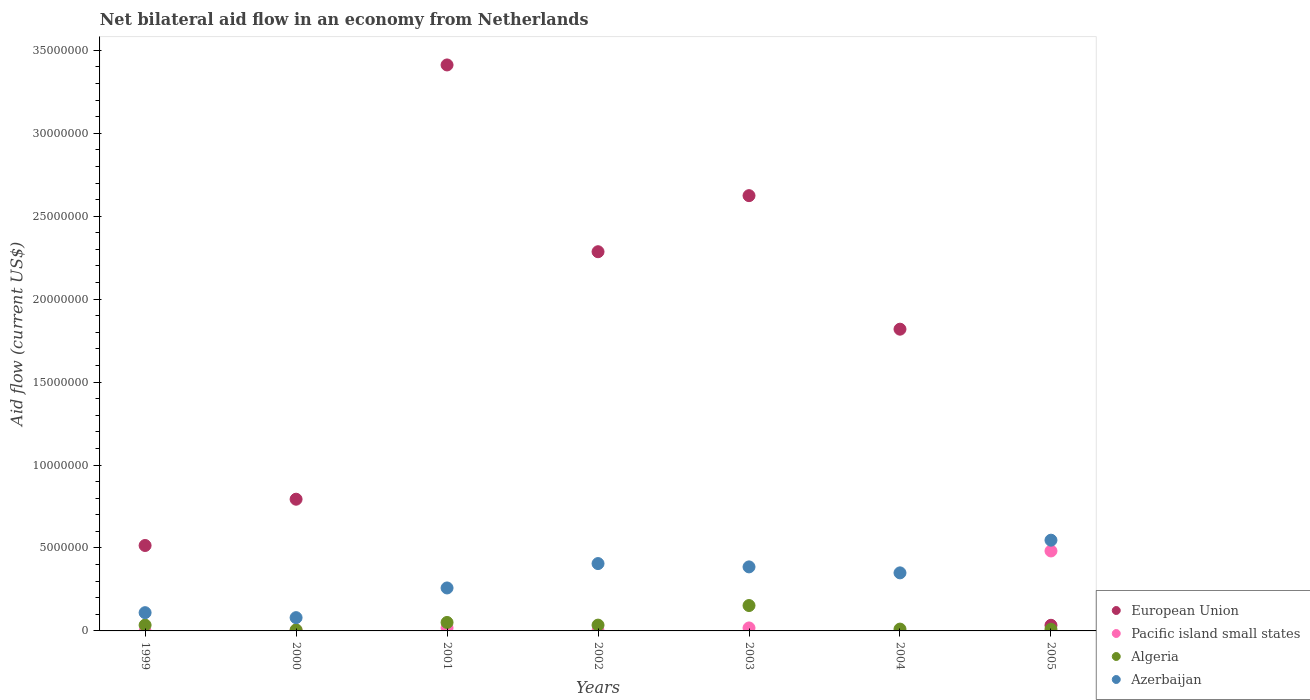Is the number of dotlines equal to the number of legend labels?
Your answer should be compact. No. What is the net bilateral aid flow in Azerbaijan in 2001?
Provide a succinct answer. 2.59e+06. Across all years, what is the maximum net bilateral aid flow in Azerbaijan?
Give a very brief answer. 5.47e+06. Across all years, what is the minimum net bilateral aid flow in Algeria?
Your answer should be very brief. 6.00e+04. In which year was the net bilateral aid flow in European Union maximum?
Give a very brief answer. 2001. What is the total net bilateral aid flow in European Union in the graph?
Provide a short and direct response. 1.15e+08. What is the difference between the net bilateral aid flow in Azerbaijan in 2000 and that in 2002?
Ensure brevity in your answer.  -3.26e+06. What is the difference between the net bilateral aid flow in Pacific island small states in 2003 and the net bilateral aid flow in European Union in 2001?
Ensure brevity in your answer.  -3.39e+07. What is the average net bilateral aid flow in Azerbaijan per year?
Offer a very short reply. 3.05e+06. In the year 2001, what is the difference between the net bilateral aid flow in Pacific island small states and net bilateral aid flow in Algeria?
Ensure brevity in your answer.  -3.30e+05. In how many years, is the net bilateral aid flow in Azerbaijan greater than 30000000 US$?
Keep it short and to the point. 0. What is the ratio of the net bilateral aid flow in European Union in 2001 to that in 2004?
Offer a terse response. 1.88. What is the difference between the highest and the second highest net bilateral aid flow in Pacific island small states?
Provide a short and direct response. 4.64e+06. What is the difference between the highest and the lowest net bilateral aid flow in European Union?
Provide a succinct answer. 3.38e+07. In how many years, is the net bilateral aid flow in Azerbaijan greater than the average net bilateral aid flow in Azerbaijan taken over all years?
Provide a short and direct response. 4. Is it the case that in every year, the sum of the net bilateral aid flow in European Union and net bilateral aid flow in Azerbaijan  is greater than the net bilateral aid flow in Algeria?
Your answer should be compact. Yes. Is the net bilateral aid flow in Azerbaijan strictly greater than the net bilateral aid flow in Pacific island small states over the years?
Your answer should be very brief. Yes. How many dotlines are there?
Provide a succinct answer. 4. How many years are there in the graph?
Provide a succinct answer. 7. Does the graph contain grids?
Offer a very short reply. No. Where does the legend appear in the graph?
Make the answer very short. Bottom right. How are the legend labels stacked?
Provide a succinct answer. Vertical. What is the title of the graph?
Provide a succinct answer. Net bilateral aid flow in an economy from Netherlands. What is the label or title of the X-axis?
Provide a succinct answer. Years. What is the Aid flow (current US$) of European Union in 1999?
Offer a very short reply. 5.15e+06. What is the Aid flow (current US$) in Azerbaijan in 1999?
Your answer should be very brief. 1.10e+06. What is the Aid flow (current US$) of European Union in 2000?
Give a very brief answer. 7.94e+06. What is the Aid flow (current US$) of European Union in 2001?
Your answer should be compact. 3.41e+07. What is the Aid flow (current US$) in Algeria in 2001?
Offer a very short reply. 5.10e+05. What is the Aid flow (current US$) of Azerbaijan in 2001?
Offer a terse response. 2.59e+06. What is the Aid flow (current US$) in European Union in 2002?
Your answer should be compact. 2.29e+07. What is the Aid flow (current US$) of Pacific island small states in 2002?
Keep it short and to the point. 10000. What is the Aid flow (current US$) in Azerbaijan in 2002?
Provide a short and direct response. 4.06e+06. What is the Aid flow (current US$) of European Union in 2003?
Your response must be concise. 2.62e+07. What is the Aid flow (current US$) in Algeria in 2003?
Provide a short and direct response. 1.53e+06. What is the Aid flow (current US$) in Azerbaijan in 2003?
Provide a short and direct response. 3.86e+06. What is the Aid flow (current US$) in European Union in 2004?
Ensure brevity in your answer.  1.82e+07. What is the Aid flow (current US$) in Azerbaijan in 2004?
Provide a succinct answer. 3.50e+06. What is the Aid flow (current US$) in Pacific island small states in 2005?
Ensure brevity in your answer.  4.82e+06. What is the Aid flow (current US$) in Azerbaijan in 2005?
Offer a very short reply. 5.47e+06. Across all years, what is the maximum Aid flow (current US$) of European Union?
Your response must be concise. 3.41e+07. Across all years, what is the maximum Aid flow (current US$) of Pacific island small states?
Ensure brevity in your answer.  4.82e+06. Across all years, what is the maximum Aid flow (current US$) in Algeria?
Ensure brevity in your answer.  1.53e+06. Across all years, what is the maximum Aid flow (current US$) of Azerbaijan?
Offer a very short reply. 5.47e+06. Across all years, what is the minimum Aid flow (current US$) of Azerbaijan?
Keep it short and to the point. 8.00e+05. What is the total Aid flow (current US$) in European Union in the graph?
Your answer should be compact. 1.15e+08. What is the total Aid flow (current US$) in Pacific island small states in the graph?
Provide a succinct answer. 5.22e+06. What is the total Aid flow (current US$) of Algeria in the graph?
Give a very brief answer. 3.01e+06. What is the total Aid flow (current US$) in Azerbaijan in the graph?
Provide a succinct answer. 2.14e+07. What is the difference between the Aid flow (current US$) in European Union in 1999 and that in 2000?
Make the answer very short. -2.79e+06. What is the difference between the Aid flow (current US$) in European Union in 1999 and that in 2001?
Keep it short and to the point. -2.90e+07. What is the difference between the Aid flow (current US$) of Algeria in 1999 and that in 2001?
Provide a short and direct response. -1.60e+05. What is the difference between the Aid flow (current US$) of Azerbaijan in 1999 and that in 2001?
Your answer should be very brief. -1.49e+06. What is the difference between the Aid flow (current US$) in European Union in 1999 and that in 2002?
Offer a terse response. -1.77e+07. What is the difference between the Aid flow (current US$) in Azerbaijan in 1999 and that in 2002?
Your answer should be very brief. -2.96e+06. What is the difference between the Aid flow (current US$) in European Union in 1999 and that in 2003?
Offer a very short reply. -2.11e+07. What is the difference between the Aid flow (current US$) of Algeria in 1999 and that in 2003?
Provide a succinct answer. -1.18e+06. What is the difference between the Aid flow (current US$) of Azerbaijan in 1999 and that in 2003?
Your answer should be very brief. -2.76e+06. What is the difference between the Aid flow (current US$) of European Union in 1999 and that in 2004?
Keep it short and to the point. -1.30e+07. What is the difference between the Aid flow (current US$) of Algeria in 1999 and that in 2004?
Your answer should be very brief. 2.40e+05. What is the difference between the Aid flow (current US$) of Azerbaijan in 1999 and that in 2004?
Ensure brevity in your answer.  -2.40e+06. What is the difference between the Aid flow (current US$) of European Union in 1999 and that in 2005?
Keep it short and to the point. 4.81e+06. What is the difference between the Aid flow (current US$) of Algeria in 1999 and that in 2005?
Provide a succinct answer. 2.50e+05. What is the difference between the Aid flow (current US$) of Azerbaijan in 1999 and that in 2005?
Provide a succinct answer. -4.37e+06. What is the difference between the Aid flow (current US$) in European Union in 2000 and that in 2001?
Offer a very short reply. -2.62e+07. What is the difference between the Aid flow (current US$) in Algeria in 2000 and that in 2001?
Your response must be concise. -4.50e+05. What is the difference between the Aid flow (current US$) of Azerbaijan in 2000 and that in 2001?
Make the answer very short. -1.79e+06. What is the difference between the Aid flow (current US$) of European Union in 2000 and that in 2002?
Your answer should be very brief. -1.49e+07. What is the difference between the Aid flow (current US$) in Pacific island small states in 2000 and that in 2002?
Your answer should be compact. 2.00e+04. What is the difference between the Aid flow (current US$) in Algeria in 2000 and that in 2002?
Provide a succinct answer. -2.90e+05. What is the difference between the Aid flow (current US$) of Azerbaijan in 2000 and that in 2002?
Your answer should be very brief. -3.26e+06. What is the difference between the Aid flow (current US$) in European Union in 2000 and that in 2003?
Your response must be concise. -1.83e+07. What is the difference between the Aid flow (current US$) in Algeria in 2000 and that in 2003?
Provide a succinct answer. -1.47e+06. What is the difference between the Aid flow (current US$) of Azerbaijan in 2000 and that in 2003?
Make the answer very short. -3.06e+06. What is the difference between the Aid flow (current US$) in European Union in 2000 and that in 2004?
Keep it short and to the point. -1.02e+07. What is the difference between the Aid flow (current US$) in Algeria in 2000 and that in 2004?
Your response must be concise. -5.00e+04. What is the difference between the Aid flow (current US$) of Azerbaijan in 2000 and that in 2004?
Offer a terse response. -2.70e+06. What is the difference between the Aid flow (current US$) of European Union in 2000 and that in 2005?
Your response must be concise. 7.60e+06. What is the difference between the Aid flow (current US$) in Pacific island small states in 2000 and that in 2005?
Your answer should be compact. -4.79e+06. What is the difference between the Aid flow (current US$) of Algeria in 2000 and that in 2005?
Provide a succinct answer. -4.00e+04. What is the difference between the Aid flow (current US$) in Azerbaijan in 2000 and that in 2005?
Ensure brevity in your answer.  -4.67e+06. What is the difference between the Aid flow (current US$) in European Union in 2001 and that in 2002?
Make the answer very short. 1.13e+07. What is the difference between the Aid flow (current US$) of Pacific island small states in 2001 and that in 2002?
Your answer should be compact. 1.70e+05. What is the difference between the Aid flow (current US$) of Azerbaijan in 2001 and that in 2002?
Give a very brief answer. -1.47e+06. What is the difference between the Aid flow (current US$) of European Union in 2001 and that in 2003?
Keep it short and to the point. 7.88e+06. What is the difference between the Aid flow (current US$) in Algeria in 2001 and that in 2003?
Your response must be concise. -1.02e+06. What is the difference between the Aid flow (current US$) of Azerbaijan in 2001 and that in 2003?
Make the answer very short. -1.27e+06. What is the difference between the Aid flow (current US$) in European Union in 2001 and that in 2004?
Offer a terse response. 1.59e+07. What is the difference between the Aid flow (current US$) of Azerbaijan in 2001 and that in 2004?
Keep it short and to the point. -9.10e+05. What is the difference between the Aid flow (current US$) of European Union in 2001 and that in 2005?
Ensure brevity in your answer.  3.38e+07. What is the difference between the Aid flow (current US$) in Pacific island small states in 2001 and that in 2005?
Your response must be concise. -4.64e+06. What is the difference between the Aid flow (current US$) of Algeria in 2001 and that in 2005?
Offer a very short reply. 4.10e+05. What is the difference between the Aid flow (current US$) of Azerbaijan in 2001 and that in 2005?
Provide a short and direct response. -2.88e+06. What is the difference between the Aid flow (current US$) of European Union in 2002 and that in 2003?
Your answer should be compact. -3.38e+06. What is the difference between the Aid flow (current US$) of Pacific island small states in 2002 and that in 2003?
Make the answer very short. -1.70e+05. What is the difference between the Aid flow (current US$) of Algeria in 2002 and that in 2003?
Give a very brief answer. -1.18e+06. What is the difference between the Aid flow (current US$) in European Union in 2002 and that in 2004?
Your answer should be compact. 4.67e+06. What is the difference between the Aid flow (current US$) in Algeria in 2002 and that in 2004?
Your answer should be compact. 2.40e+05. What is the difference between the Aid flow (current US$) of Azerbaijan in 2002 and that in 2004?
Offer a terse response. 5.60e+05. What is the difference between the Aid flow (current US$) in European Union in 2002 and that in 2005?
Make the answer very short. 2.25e+07. What is the difference between the Aid flow (current US$) of Pacific island small states in 2002 and that in 2005?
Provide a succinct answer. -4.81e+06. What is the difference between the Aid flow (current US$) of Algeria in 2002 and that in 2005?
Your response must be concise. 2.50e+05. What is the difference between the Aid flow (current US$) of Azerbaijan in 2002 and that in 2005?
Your answer should be compact. -1.41e+06. What is the difference between the Aid flow (current US$) of European Union in 2003 and that in 2004?
Your answer should be compact. 8.05e+06. What is the difference between the Aid flow (current US$) of Algeria in 2003 and that in 2004?
Provide a succinct answer. 1.42e+06. What is the difference between the Aid flow (current US$) in Azerbaijan in 2003 and that in 2004?
Your answer should be very brief. 3.60e+05. What is the difference between the Aid flow (current US$) of European Union in 2003 and that in 2005?
Your answer should be compact. 2.59e+07. What is the difference between the Aid flow (current US$) in Pacific island small states in 2003 and that in 2005?
Your answer should be compact. -4.64e+06. What is the difference between the Aid flow (current US$) of Algeria in 2003 and that in 2005?
Offer a very short reply. 1.43e+06. What is the difference between the Aid flow (current US$) of Azerbaijan in 2003 and that in 2005?
Provide a short and direct response. -1.61e+06. What is the difference between the Aid flow (current US$) in European Union in 2004 and that in 2005?
Ensure brevity in your answer.  1.78e+07. What is the difference between the Aid flow (current US$) in Algeria in 2004 and that in 2005?
Keep it short and to the point. 10000. What is the difference between the Aid flow (current US$) of Azerbaijan in 2004 and that in 2005?
Provide a succinct answer. -1.97e+06. What is the difference between the Aid flow (current US$) of European Union in 1999 and the Aid flow (current US$) of Pacific island small states in 2000?
Keep it short and to the point. 5.12e+06. What is the difference between the Aid flow (current US$) in European Union in 1999 and the Aid flow (current US$) in Algeria in 2000?
Your answer should be compact. 5.09e+06. What is the difference between the Aid flow (current US$) of European Union in 1999 and the Aid flow (current US$) of Azerbaijan in 2000?
Offer a terse response. 4.35e+06. What is the difference between the Aid flow (current US$) of Algeria in 1999 and the Aid flow (current US$) of Azerbaijan in 2000?
Ensure brevity in your answer.  -4.50e+05. What is the difference between the Aid flow (current US$) in European Union in 1999 and the Aid flow (current US$) in Pacific island small states in 2001?
Make the answer very short. 4.97e+06. What is the difference between the Aid flow (current US$) of European Union in 1999 and the Aid flow (current US$) of Algeria in 2001?
Make the answer very short. 4.64e+06. What is the difference between the Aid flow (current US$) in European Union in 1999 and the Aid flow (current US$) in Azerbaijan in 2001?
Offer a very short reply. 2.56e+06. What is the difference between the Aid flow (current US$) of Algeria in 1999 and the Aid flow (current US$) of Azerbaijan in 2001?
Offer a very short reply. -2.24e+06. What is the difference between the Aid flow (current US$) of European Union in 1999 and the Aid flow (current US$) of Pacific island small states in 2002?
Your answer should be compact. 5.14e+06. What is the difference between the Aid flow (current US$) in European Union in 1999 and the Aid flow (current US$) in Algeria in 2002?
Your response must be concise. 4.80e+06. What is the difference between the Aid flow (current US$) of European Union in 1999 and the Aid flow (current US$) of Azerbaijan in 2002?
Your answer should be compact. 1.09e+06. What is the difference between the Aid flow (current US$) in Algeria in 1999 and the Aid flow (current US$) in Azerbaijan in 2002?
Provide a succinct answer. -3.71e+06. What is the difference between the Aid flow (current US$) in European Union in 1999 and the Aid flow (current US$) in Pacific island small states in 2003?
Offer a terse response. 4.97e+06. What is the difference between the Aid flow (current US$) in European Union in 1999 and the Aid flow (current US$) in Algeria in 2003?
Make the answer very short. 3.62e+06. What is the difference between the Aid flow (current US$) of European Union in 1999 and the Aid flow (current US$) of Azerbaijan in 2003?
Make the answer very short. 1.29e+06. What is the difference between the Aid flow (current US$) of Algeria in 1999 and the Aid flow (current US$) of Azerbaijan in 2003?
Your response must be concise. -3.51e+06. What is the difference between the Aid flow (current US$) of European Union in 1999 and the Aid flow (current US$) of Algeria in 2004?
Your answer should be compact. 5.04e+06. What is the difference between the Aid flow (current US$) in European Union in 1999 and the Aid flow (current US$) in Azerbaijan in 2004?
Provide a short and direct response. 1.65e+06. What is the difference between the Aid flow (current US$) of Algeria in 1999 and the Aid flow (current US$) of Azerbaijan in 2004?
Your answer should be compact. -3.15e+06. What is the difference between the Aid flow (current US$) of European Union in 1999 and the Aid flow (current US$) of Algeria in 2005?
Provide a short and direct response. 5.05e+06. What is the difference between the Aid flow (current US$) in European Union in 1999 and the Aid flow (current US$) in Azerbaijan in 2005?
Your answer should be very brief. -3.20e+05. What is the difference between the Aid flow (current US$) in Algeria in 1999 and the Aid flow (current US$) in Azerbaijan in 2005?
Ensure brevity in your answer.  -5.12e+06. What is the difference between the Aid flow (current US$) of European Union in 2000 and the Aid flow (current US$) of Pacific island small states in 2001?
Make the answer very short. 7.76e+06. What is the difference between the Aid flow (current US$) in European Union in 2000 and the Aid flow (current US$) in Algeria in 2001?
Provide a succinct answer. 7.43e+06. What is the difference between the Aid flow (current US$) of European Union in 2000 and the Aid flow (current US$) of Azerbaijan in 2001?
Ensure brevity in your answer.  5.35e+06. What is the difference between the Aid flow (current US$) of Pacific island small states in 2000 and the Aid flow (current US$) of Algeria in 2001?
Offer a terse response. -4.80e+05. What is the difference between the Aid flow (current US$) in Pacific island small states in 2000 and the Aid flow (current US$) in Azerbaijan in 2001?
Provide a succinct answer. -2.56e+06. What is the difference between the Aid flow (current US$) in Algeria in 2000 and the Aid flow (current US$) in Azerbaijan in 2001?
Your answer should be compact. -2.53e+06. What is the difference between the Aid flow (current US$) in European Union in 2000 and the Aid flow (current US$) in Pacific island small states in 2002?
Your response must be concise. 7.93e+06. What is the difference between the Aid flow (current US$) of European Union in 2000 and the Aid flow (current US$) of Algeria in 2002?
Provide a short and direct response. 7.59e+06. What is the difference between the Aid flow (current US$) in European Union in 2000 and the Aid flow (current US$) in Azerbaijan in 2002?
Offer a very short reply. 3.88e+06. What is the difference between the Aid flow (current US$) of Pacific island small states in 2000 and the Aid flow (current US$) of Algeria in 2002?
Keep it short and to the point. -3.20e+05. What is the difference between the Aid flow (current US$) in Pacific island small states in 2000 and the Aid flow (current US$) in Azerbaijan in 2002?
Provide a short and direct response. -4.03e+06. What is the difference between the Aid flow (current US$) of European Union in 2000 and the Aid flow (current US$) of Pacific island small states in 2003?
Make the answer very short. 7.76e+06. What is the difference between the Aid flow (current US$) of European Union in 2000 and the Aid flow (current US$) of Algeria in 2003?
Offer a very short reply. 6.41e+06. What is the difference between the Aid flow (current US$) in European Union in 2000 and the Aid flow (current US$) in Azerbaijan in 2003?
Offer a very short reply. 4.08e+06. What is the difference between the Aid flow (current US$) in Pacific island small states in 2000 and the Aid flow (current US$) in Algeria in 2003?
Your response must be concise. -1.50e+06. What is the difference between the Aid flow (current US$) in Pacific island small states in 2000 and the Aid flow (current US$) in Azerbaijan in 2003?
Provide a succinct answer. -3.83e+06. What is the difference between the Aid flow (current US$) of Algeria in 2000 and the Aid flow (current US$) of Azerbaijan in 2003?
Provide a short and direct response. -3.80e+06. What is the difference between the Aid flow (current US$) of European Union in 2000 and the Aid flow (current US$) of Algeria in 2004?
Make the answer very short. 7.83e+06. What is the difference between the Aid flow (current US$) in European Union in 2000 and the Aid flow (current US$) in Azerbaijan in 2004?
Your answer should be compact. 4.44e+06. What is the difference between the Aid flow (current US$) of Pacific island small states in 2000 and the Aid flow (current US$) of Algeria in 2004?
Provide a succinct answer. -8.00e+04. What is the difference between the Aid flow (current US$) in Pacific island small states in 2000 and the Aid flow (current US$) in Azerbaijan in 2004?
Make the answer very short. -3.47e+06. What is the difference between the Aid flow (current US$) of Algeria in 2000 and the Aid flow (current US$) of Azerbaijan in 2004?
Keep it short and to the point. -3.44e+06. What is the difference between the Aid flow (current US$) of European Union in 2000 and the Aid flow (current US$) of Pacific island small states in 2005?
Your answer should be compact. 3.12e+06. What is the difference between the Aid flow (current US$) of European Union in 2000 and the Aid flow (current US$) of Algeria in 2005?
Your answer should be compact. 7.84e+06. What is the difference between the Aid flow (current US$) of European Union in 2000 and the Aid flow (current US$) of Azerbaijan in 2005?
Offer a terse response. 2.47e+06. What is the difference between the Aid flow (current US$) in Pacific island small states in 2000 and the Aid flow (current US$) in Algeria in 2005?
Offer a terse response. -7.00e+04. What is the difference between the Aid flow (current US$) in Pacific island small states in 2000 and the Aid flow (current US$) in Azerbaijan in 2005?
Provide a succinct answer. -5.44e+06. What is the difference between the Aid flow (current US$) of Algeria in 2000 and the Aid flow (current US$) of Azerbaijan in 2005?
Give a very brief answer. -5.41e+06. What is the difference between the Aid flow (current US$) in European Union in 2001 and the Aid flow (current US$) in Pacific island small states in 2002?
Ensure brevity in your answer.  3.41e+07. What is the difference between the Aid flow (current US$) of European Union in 2001 and the Aid flow (current US$) of Algeria in 2002?
Provide a short and direct response. 3.38e+07. What is the difference between the Aid flow (current US$) of European Union in 2001 and the Aid flow (current US$) of Azerbaijan in 2002?
Your answer should be compact. 3.01e+07. What is the difference between the Aid flow (current US$) in Pacific island small states in 2001 and the Aid flow (current US$) in Algeria in 2002?
Your answer should be compact. -1.70e+05. What is the difference between the Aid flow (current US$) in Pacific island small states in 2001 and the Aid flow (current US$) in Azerbaijan in 2002?
Offer a terse response. -3.88e+06. What is the difference between the Aid flow (current US$) of Algeria in 2001 and the Aid flow (current US$) of Azerbaijan in 2002?
Your answer should be compact. -3.55e+06. What is the difference between the Aid flow (current US$) in European Union in 2001 and the Aid flow (current US$) in Pacific island small states in 2003?
Offer a terse response. 3.39e+07. What is the difference between the Aid flow (current US$) in European Union in 2001 and the Aid flow (current US$) in Algeria in 2003?
Offer a very short reply. 3.26e+07. What is the difference between the Aid flow (current US$) of European Union in 2001 and the Aid flow (current US$) of Azerbaijan in 2003?
Provide a succinct answer. 3.03e+07. What is the difference between the Aid flow (current US$) of Pacific island small states in 2001 and the Aid flow (current US$) of Algeria in 2003?
Give a very brief answer. -1.35e+06. What is the difference between the Aid flow (current US$) in Pacific island small states in 2001 and the Aid flow (current US$) in Azerbaijan in 2003?
Provide a short and direct response. -3.68e+06. What is the difference between the Aid flow (current US$) in Algeria in 2001 and the Aid flow (current US$) in Azerbaijan in 2003?
Ensure brevity in your answer.  -3.35e+06. What is the difference between the Aid flow (current US$) of European Union in 2001 and the Aid flow (current US$) of Algeria in 2004?
Make the answer very short. 3.40e+07. What is the difference between the Aid flow (current US$) in European Union in 2001 and the Aid flow (current US$) in Azerbaijan in 2004?
Provide a succinct answer. 3.06e+07. What is the difference between the Aid flow (current US$) of Pacific island small states in 2001 and the Aid flow (current US$) of Algeria in 2004?
Ensure brevity in your answer.  7.00e+04. What is the difference between the Aid flow (current US$) of Pacific island small states in 2001 and the Aid flow (current US$) of Azerbaijan in 2004?
Give a very brief answer. -3.32e+06. What is the difference between the Aid flow (current US$) in Algeria in 2001 and the Aid flow (current US$) in Azerbaijan in 2004?
Make the answer very short. -2.99e+06. What is the difference between the Aid flow (current US$) of European Union in 2001 and the Aid flow (current US$) of Pacific island small states in 2005?
Ensure brevity in your answer.  2.93e+07. What is the difference between the Aid flow (current US$) of European Union in 2001 and the Aid flow (current US$) of Algeria in 2005?
Ensure brevity in your answer.  3.40e+07. What is the difference between the Aid flow (current US$) of European Union in 2001 and the Aid flow (current US$) of Azerbaijan in 2005?
Keep it short and to the point. 2.86e+07. What is the difference between the Aid flow (current US$) in Pacific island small states in 2001 and the Aid flow (current US$) in Algeria in 2005?
Ensure brevity in your answer.  8.00e+04. What is the difference between the Aid flow (current US$) in Pacific island small states in 2001 and the Aid flow (current US$) in Azerbaijan in 2005?
Offer a very short reply. -5.29e+06. What is the difference between the Aid flow (current US$) of Algeria in 2001 and the Aid flow (current US$) of Azerbaijan in 2005?
Keep it short and to the point. -4.96e+06. What is the difference between the Aid flow (current US$) in European Union in 2002 and the Aid flow (current US$) in Pacific island small states in 2003?
Offer a terse response. 2.27e+07. What is the difference between the Aid flow (current US$) of European Union in 2002 and the Aid flow (current US$) of Algeria in 2003?
Your answer should be very brief. 2.13e+07. What is the difference between the Aid flow (current US$) in European Union in 2002 and the Aid flow (current US$) in Azerbaijan in 2003?
Your answer should be very brief. 1.90e+07. What is the difference between the Aid flow (current US$) in Pacific island small states in 2002 and the Aid flow (current US$) in Algeria in 2003?
Offer a very short reply. -1.52e+06. What is the difference between the Aid flow (current US$) in Pacific island small states in 2002 and the Aid flow (current US$) in Azerbaijan in 2003?
Your answer should be compact. -3.85e+06. What is the difference between the Aid flow (current US$) of Algeria in 2002 and the Aid flow (current US$) of Azerbaijan in 2003?
Provide a succinct answer. -3.51e+06. What is the difference between the Aid flow (current US$) of European Union in 2002 and the Aid flow (current US$) of Algeria in 2004?
Ensure brevity in your answer.  2.28e+07. What is the difference between the Aid flow (current US$) in European Union in 2002 and the Aid flow (current US$) in Azerbaijan in 2004?
Make the answer very short. 1.94e+07. What is the difference between the Aid flow (current US$) of Pacific island small states in 2002 and the Aid flow (current US$) of Algeria in 2004?
Provide a short and direct response. -1.00e+05. What is the difference between the Aid flow (current US$) in Pacific island small states in 2002 and the Aid flow (current US$) in Azerbaijan in 2004?
Offer a terse response. -3.49e+06. What is the difference between the Aid flow (current US$) in Algeria in 2002 and the Aid flow (current US$) in Azerbaijan in 2004?
Ensure brevity in your answer.  -3.15e+06. What is the difference between the Aid flow (current US$) in European Union in 2002 and the Aid flow (current US$) in Pacific island small states in 2005?
Provide a succinct answer. 1.80e+07. What is the difference between the Aid flow (current US$) in European Union in 2002 and the Aid flow (current US$) in Algeria in 2005?
Offer a very short reply. 2.28e+07. What is the difference between the Aid flow (current US$) in European Union in 2002 and the Aid flow (current US$) in Azerbaijan in 2005?
Offer a very short reply. 1.74e+07. What is the difference between the Aid flow (current US$) in Pacific island small states in 2002 and the Aid flow (current US$) in Algeria in 2005?
Your answer should be very brief. -9.00e+04. What is the difference between the Aid flow (current US$) of Pacific island small states in 2002 and the Aid flow (current US$) of Azerbaijan in 2005?
Provide a succinct answer. -5.46e+06. What is the difference between the Aid flow (current US$) in Algeria in 2002 and the Aid flow (current US$) in Azerbaijan in 2005?
Your answer should be very brief. -5.12e+06. What is the difference between the Aid flow (current US$) of European Union in 2003 and the Aid flow (current US$) of Algeria in 2004?
Give a very brief answer. 2.61e+07. What is the difference between the Aid flow (current US$) of European Union in 2003 and the Aid flow (current US$) of Azerbaijan in 2004?
Offer a very short reply. 2.27e+07. What is the difference between the Aid flow (current US$) of Pacific island small states in 2003 and the Aid flow (current US$) of Algeria in 2004?
Make the answer very short. 7.00e+04. What is the difference between the Aid flow (current US$) in Pacific island small states in 2003 and the Aid flow (current US$) in Azerbaijan in 2004?
Make the answer very short. -3.32e+06. What is the difference between the Aid flow (current US$) in Algeria in 2003 and the Aid flow (current US$) in Azerbaijan in 2004?
Provide a short and direct response. -1.97e+06. What is the difference between the Aid flow (current US$) of European Union in 2003 and the Aid flow (current US$) of Pacific island small states in 2005?
Ensure brevity in your answer.  2.14e+07. What is the difference between the Aid flow (current US$) of European Union in 2003 and the Aid flow (current US$) of Algeria in 2005?
Provide a succinct answer. 2.61e+07. What is the difference between the Aid flow (current US$) in European Union in 2003 and the Aid flow (current US$) in Azerbaijan in 2005?
Your answer should be very brief. 2.08e+07. What is the difference between the Aid flow (current US$) of Pacific island small states in 2003 and the Aid flow (current US$) of Algeria in 2005?
Provide a short and direct response. 8.00e+04. What is the difference between the Aid flow (current US$) of Pacific island small states in 2003 and the Aid flow (current US$) of Azerbaijan in 2005?
Offer a terse response. -5.29e+06. What is the difference between the Aid flow (current US$) of Algeria in 2003 and the Aid flow (current US$) of Azerbaijan in 2005?
Provide a succinct answer. -3.94e+06. What is the difference between the Aid flow (current US$) in European Union in 2004 and the Aid flow (current US$) in Pacific island small states in 2005?
Your answer should be very brief. 1.34e+07. What is the difference between the Aid flow (current US$) of European Union in 2004 and the Aid flow (current US$) of Algeria in 2005?
Your answer should be very brief. 1.81e+07. What is the difference between the Aid flow (current US$) of European Union in 2004 and the Aid flow (current US$) of Azerbaijan in 2005?
Keep it short and to the point. 1.27e+07. What is the difference between the Aid flow (current US$) in Algeria in 2004 and the Aid flow (current US$) in Azerbaijan in 2005?
Provide a succinct answer. -5.36e+06. What is the average Aid flow (current US$) of European Union per year?
Give a very brief answer. 1.64e+07. What is the average Aid flow (current US$) in Pacific island small states per year?
Your answer should be very brief. 7.46e+05. What is the average Aid flow (current US$) in Algeria per year?
Your answer should be compact. 4.30e+05. What is the average Aid flow (current US$) in Azerbaijan per year?
Your response must be concise. 3.05e+06. In the year 1999, what is the difference between the Aid flow (current US$) of European Union and Aid flow (current US$) of Algeria?
Ensure brevity in your answer.  4.80e+06. In the year 1999, what is the difference between the Aid flow (current US$) in European Union and Aid flow (current US$) in Azerbaijan?
Offer a terse response. 4.05e+06. In the year 1999, what is the difference between the Aid flow (current US$) of Algeria and Aid flow (current US$) of Azerbaijan?
Your answer should be very brief. -7.50e+05. In the year 2000, what is the difference between the Aid flow (current US$) of European Union and Aid flow (current US$) of Pacific island small states?
Offer a very short reply. 7.91e+06. In the year 2000, what is the difference between the Aid flow (current US$) in European Union and Aid flow (current US$) in Algeria?
Offer a terse response. 7.88e+06. In the year 2000, what is the difference between the Aid flow (current US$) in European Union and Aid flow (current US$) in Azerbaijan?
Your response must be concise. 7.14e+06. In the year 2000, what is the difference between the Aid flow (current US$) in Pacific island small states and Aid flow (current US$) in Azerbaijan?
Offer a terse response. -7.70e+05. In the year 2000, what is the difference between the Aid flow (current US$) of Algeria and Aid flow (current US$) of Azerbaijan?
Offer a terse response. -7.40e+05. In the year 2001, what is the difference between the Aid flow (current US$) in European Union and Aid flow (current US$) in Pacific island small states?
Ensure brevity in your answer.  3.39e+07. In the year 2001, what is the difference between the Aid flow (current US$) of European Union and Aid flow (current US$) of Algeria?
Offer a terse response. 3.36e+07. In the year 2001, what is the difference between the Aid flow (current US$) of European Union and Aid flow (current US$) of Azerbaijan?
Provide a succinct answer. 3.15e+07. In the year 2001, what is the difference between the Aid flow (current US$) in Pacific island small states and Aid flow (current US$) in Algeria?
Your answer should be compact. -3.30e+05. In the year 2001, what is the difference between the Aid flow (current US$) of Pacific island small states and Aid flow (current US$) of Azerbaijan?
Ensure brevity in your answer.  -2.41e+06. In the year 2001, what is the difference between the Aid flow (current US$) of Algeria and Aid flow (current US$) of Azerbaijan?
Your answer should be very brief. -2.08e+06. In the year 2002, what is the difference between the Aid flow (current US$) of European Union and Aid flow (current US$) of Pacific island small states?
Ensure brevity in your answer.  2.28e+07. In the year 2002, what is the difference between the Aid flow (current US$) in European Union and Aid flow (current US$) in Algeria?
Your answer should be very brief. 2.25e+07. In the year 2002, what is the difference between the Aid flow (current US$) of European Union and Aid flow (current US$) of Azerbaijan?
Make the answer very short. 1.88e+07. In the year 2002, what is the difference between the Aid flow (current US$) of Pacific island small states and Aid flow (current US$) of Azerbaijan?
Offer a very short reply. -4.05e+06. In the year 2002, what is the difference between the Aid flow (current US$) of Algeria and Aid flow (current US$) of Azerbaijan?
Ensure brevity in your answer.  -3.71e+06. In the year 2003, what is the difference between the Aid flow (current US$) in European Union and Aid flow (current US$) in Pacific island small states?
Give a very brief answer. 2.61e+07. In the year 2003, what is the difference between the Aid flow (current US$) of European Union and Aid flow (current US$) of Algeria?
Make the answer very short. 2.47e+07. In the year 2003, what is the difference between the Aid flow (current US$) of European Union and Aid flow (current US$) of Azerbaijan?
Your answer should be compact. 2.24e+07. In the year 2003, what is the difference between the Aid flow (current US$) in Pacific island small states and Aid flow (current US$) in Algeria?
Provide a succinct answer. -1.35e+06. In the year 2003, what is the difference between the Aid flow (current US$) of Pacific island small states and Aid flow (current US$) of Azerbaijan?
Make the answer very short. -3.68e+06. In the year 2003, what is the difference between the Aid flow (current US$) of Algeria and Aid flow (current US$) of Azerbaijan?
Your answer should be very brief. -2.33e+06. In the year 2004, what is the difference between the Aid flow (current US$) in European Union and Aid flow (current US$) in Algeria?
Make the answer very short. 1.81e+07. In the year 2004, what is the difference between the Aid flow (current US$) of European Union and Aid flow (current US$) of Azerbaijan?
Provide a short and direct response. 1.47e+07. In the year 2004, what is the difference between the Aid flow (current US$) of Algeria and Aid flow (current US$) of Azerbaijan?
Ensure brevity in your answer.  -3.39e+06. In the year 2005, what is the difference between the Aid flow (current US$) of European Union and Aid flow (current US$) of Pacific island small states?
Your response must be concise. -4.48e+06. In the year 2005, what is the difference between the Aid flow (current US$) of European Union and Aid flow (current US$) of Algeria?
Ensure brevity in your answer.  2.40e+05. In the year 2005, what is the difference between the Aid flow (current US$) in European Union and Aid flow (current US$) in Azerbaijan?
Ensure brevity in your answer.  -5.13e+06. In the year 2005, what is the difference between the Aid flow (current US$) of Pacific island small states and Aid flow (current US$) of Algeria?
Keep it short and to the point. 4.72e+06. In the year 2005, what is the difference between the Aid flow (current US$) in Pacific island small states and Aid flow (current US$) in Azerbaijan?
Offer a very short reply. -6.50e+05. In the year 2005, what is the difference between the Aid flow (current US$) of Algeria and Aid flow (current US$) of Azerbaijan?
Keep it short and to the point. -5.37e+06. What is the ratio of the Aid flow (current US$) of European Union in 1999 to that in 2000?
Give a very brief answer. 0.65. What is the ratio of the Aid flow (current US$) in Algeria in 1999 to that in 2000?
Your answer should be compact. 5.83. What is the ratio of the Aid flow (current US$) of Azerbaijan in 1999 to that in 2000?
Your answer should be very brief. 1.38. What is the ratio of the Aid flow (current US$) in European Union in 1999 to that in 2001?
Give a very brief answer. 0.15. What is the ratio of the Aid flow (current US$) of Algeria in 1999 to that in 2001?
Your response must be concise. 0.69. What is the ratio of the Aid flow (current US$) of Azerbaijan in 1999 to that in 2001?
Provide a short and direct response. 0.42. What is the ratio of the Aid flow (current US$) in European Union in 1999 to that in 2002?
Your answer should be very brief. 0.23. What is the ratio of the Aid flow (current US$) in Algeria in 1999 to that in 2002?
Your response must be concise. 1. What is the ratio of the Aid flow (current US$) of Azerbaijan in 1999 to that in 2002?
Provide a succinct answer. 0.27. What is the ratio of the Aid flow (current US$) of European Union in 1999 to that in 2003?
Ensure brevity in your answer.  0.2. What is the ratio of the Aid flow (current US$) of Algeria in 1999 to that in 2003?
Keep it short and to the point. 0.23. What is the ratio of the Aid flow (current US$) of Azerbaijan in 1999 to that in 2003?
Your answer should be compact. 0.28. What is the ratio of the Aid flow (current US$) of European Union in 1999 to that in 2004?
Provide a succinct answer. 0.28. What is the ratio of the Aid flow (current US$) of Algeria in 1999 to that in 2004?
Give a very brief answer. 3.18. What is the ratio of the Aid flow (current US$) in Azerbaijan in 1999 to that in 2004?
Provide a short and direct response. 0.31. What is the ratio of the Aid flow (current US$) of European Union in 1999 to that in 2005?
Keep it short and to the point. 15.15. What is the ratio of the Aid flow (current US$) of Azerbaijan in 1999 to that in 2005?
Keep it short and to the point. 0.2. What is the ratio of the Aid flow (current US$) in European Union in 2000 to that in 2001?
Your answer should be compact. 0.23. What is the ratio of the Aid flow (current US$) of Pacific island small states in 2000 to that in 2001?
Make the answer very short. 0.17. What is the ratio of the Aid flow (current US$) of Algeria in 2000 to that in 2001?
Keep it short and to the point. 0.12. What is the ratio of the Aid flow (current US$) of Azerbaijan in 2000 to that in 2001?
Your response must be concise. 0.31. What is the ratio of the Aid flow (current US$) of European Union in 2000 to that in 2002?
Your answer should be very brief. 0.35. What is the ratio of the Aid flow (current US$) of Algeria in 2000 to that in 2002?
Make the answer very short. 0.17. What is the ratio of the Aid flow (current US$) of Azerbaijan in 2000 to that in 2002?
Provide a succinct answer. 0.2. What is the ratio of the Aid flow (current US$) of European Union in 2000 to that in 2003?
Give a very brief answer. 0.3. What is the ratio of the Aid flow (current US$) in Algeria in 2000 to that in 2003?
Your answer should be compact. 0.04. What is the ratio of the Aid flow (current US$) in Azerbaijan in 2000 to that in 2003?
Ensure brevity in your answer.  0.21. What is the ratio of the Aid flow (current US$) in European Union in 2000 to that in 2004?
Your answer should be very brief. 0.44. What is the ratio of the Aid flow (current US$) of Algeria in 2000 to that in 2004?
Provide a succinct answer. 0.55. What is the ratio of the Aid flow (current US$) in Azerbaijan in 2000 to that in 2004?
Your response must be concise. 0.23. What is the ratio of the Aid flow (current US$) in European Union in 2000 to that in 2005?
Provide a succinct answer. 23.35. What is the ratio of the Aid flow (current US$) in Pacific island small states in 2000 to that in 2005?
Keep it short and to the point. 0.01. What is the ratio of the Aid flow (current US$) of Azerbaijan in 2000 to that in 2005?
Your answer should be compact. 0.15. What is the ratio of the Aid flow (current US$) of European Union in 2001 to that in 2002?
Offer a very short reply. 1.49. What is the ratio of the Aid flow (current US$) in Pacific island small states in 2001 to that in 2002?
Make the answer very short. 18. What is the ratio of the Aid flow (current US$) in Algeria in 2001 to that in 2002?
Offer a very short reply. 1.46. What is the ratio of the Aid flow (current US$) of Azerbaijan in 2001 to that in 2002?
Give a very brief answer. 0.64. What is the ratio of the Aid flow (current US$) of European Union in 2001 to that in 2003?
Make the answer very short. 1.3. What is the ratio of the Aid flow (current US$) in Pacific island small states in 2001 to that in 2003?
Provide a succinct answer. 1. What is the ratio of the Aid flow (current US$) in Azerbaijan in 2001 to that in 2003?
Your answer should be compact. 0.67. What is the ratio of the Aid flow (current US$) in European Union in 2001 to that in 2004?
Make the answer very short. 1.88. What is the ratio of the Aid flow (current US$) of Algeria in 2001 to that in 2004?
Offer a very short reply. 4.64. What is the ratio of the Aid flow (current US$) in Azerbaijan in 2001 to that in 2004?
Your answer should be compact. 0.74. What is the ratio of the Aid flow (current US$) of European Union in 2001 to that in 2005?
Your answer should be very brief. 100.35. What is the ratio of the Aid flow (current US$) of Pacific island small states in 2001 to that in 2005?
Provide a short and direct response. 0.04. What is the ratio of the Aid flow (current US$) of Azerbaijan in 2001 to that in 2005?
Your response must be concise. 0.47. What is the ratio of the Aid flow (current US$) of European Union in 2002 to that in 2003?
Your answer should be very brief. 0.87. What is the ratio of the Aid flow (current US$) in Pacific island small states in 2002 to that in 2003?
Ensure brevity in your answer.  0.06. What is the ratio of the Aid flow (current US$) of Algeria in 2002 to that in 2003?
Give a very brief answer. 0.23. What is the ratio of the Aid flow (current US$) in Azerbaijan in 2002 to that in 2003?
Your answer should be very brief. 1.05. What is the ratio of the Aid flow (current US$) of European Union in 2002 to that in 2004?
Ensure brevity in your answer.  1.26. What is the ratio of the Aid flow (current US$) in Algeria in 2002 to that in 2004?
Ensure brevity in your answer.  3.18. What is the ratio of the Aid flow (current US$) of Azerbaijan in 2002 to that in 2004?
Keep it short and to the point. 1.16. What is the ratio of the Aid flow (current US$) of European Union in 2002 to that in 2005?
Your answer should be compact. 67.24. What is the ratio of the Aid flow (current US$) in Pacific island small states in 2002 to that in 2005?
Ensure brevity in your answer.  0. What is the ratio of the Aid flow (current US$) of Algeria in 2002 to that in 2005?
Your answer should be very brief. 3.5. What is the ratio of the Aid flow (current US$) of Azerbaijan in 2002 to that in 2005?
Ensure brevity in your answer.  0.74. What is the ratio of the Aid flow (current US$) in European Union in 2003 to that in 2004?
Your answer should be very brief. 1.44. What is the ratio of the Aid flow (current US$) of Algeria in 2003 to that in 2004?
Offer a terse response. 13.91. What is the ratio of the Aid flow (current US$) of Azerbaijan in 2003 to that in 2004?
Make the answer very short. 1.1. What is the ratio of the Aid flow (current US$) of European Union in 2003 to that in 2005?
Offer a very short reply. 77.18. What is the ratio of the Aid flow (current US$) of Pacific island small states in 2003 to that in 2005?
Offer a very short reply. 0.04. What is the ratio of the Aid flow (current US$) of Algeria in 2003 to that in 2005?
Offer a very short reply. 15.3. What is the ratio of the Aid flow (current US$) of Azerbaijan in 2003 to that in 2005?
Ensure brevity in your answer.  0.71. What is the ratio of the Aid flow (current US$) of European Union in 2004 to that in 2005?
Give a very brief answer. 53.5. What is the ratio of the Aid flow (current US$) of Azerbaijan in 2004 to that in 2005?
Make the answer very short. 0.64. What is the difference between the highest and the second highest Aid flow (current US$) of European Union?
Your answer should be compact. 7.88e+06. What is the difference between the highest and the second highest Aid flow (current US$) in Pacific island small states?
Your answer should be compact. 4.64e+06. What is the difference between the highest and the second highest Aid flow (current US$) in Algeria?
Your answer should be compact. 1.02e+06. What is the difference between the highest and the second highest Aid flow (current US$) in Azerbaijan?
Give a very brief answer. 1.41e+06. What is the difference between the highest and the lowest Aid flow (current US$) in European Union?
Your answer should be compact. 3.38e+07. What is the difference between the highest and the lowest Aid flow (current US$) in Pacific island small states?
Offer a terse response. 4.82e+06. What is the difference between the highest and the lowest Aid flow (current US$) in Algeria?
Provide a short and direct response. 1.47e+06. What is the difference between the highest and the lowest Aid flow (current US$) of Azerbaijan?
Give a very brief answer. 4.67e+06. 